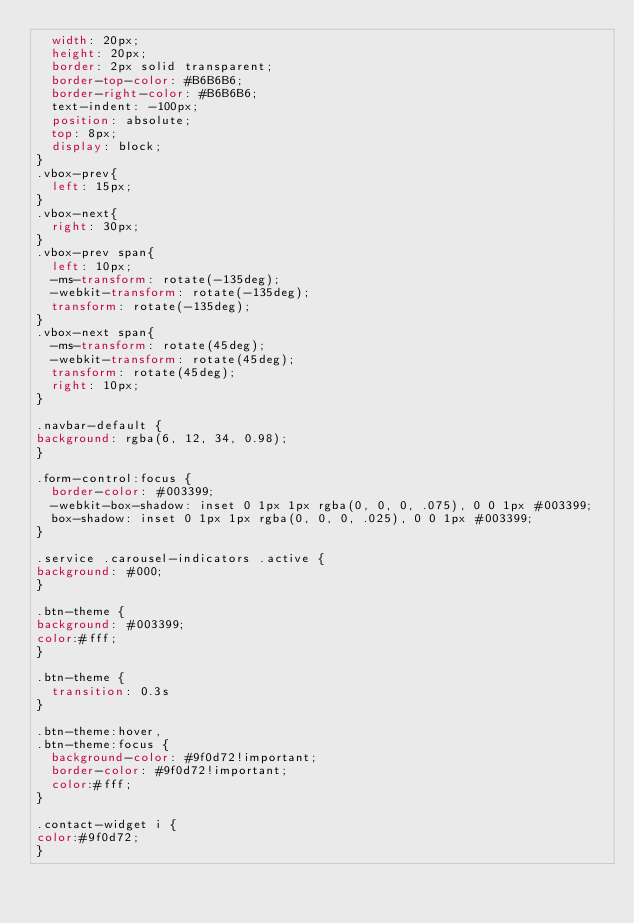Convert code to text. <code><loc_0><loc_0><loc_500><loc_500><_CSS_>  width: 20px;
  height: 20px;
  border: 2px solid transparent;
  border-top-color: #B6B6B6;
  border-right-color: #B6B6B6;
  text-indent: -100px;
  position: absolute;
  top: 8px;
  display: block;
}
.vbox-prev{
  left: 15px;
}
.vbox-next{
  right: 30px;
}
.vbox-prev span{
  left: 10px;
  -ms-transform: rotate(-135deg);
  -webkit-transform: rotate(-135deg);
  transform: rotate(-135deg);
}
.vbox-next span{
  -ms-transform: rotate(45deg);
  -webkit-transform: rotate(45deg);
  transform: rotate(45deg);
  right: 10px;
}

.navbar-default {
background: rgba(6, 12, 34, 0.98);
}

.form-control:focus {
  border-color: #003399;
  -webkit-box-shadow: inset 0 1px 1px rgba(0, 0, 0, .075), 0 0 1px #003399;
  box-shadow: inset 0 1px 1px rgba(0, 0, 0, .025), 0 0 1px #003399;
}

.service .carousel-indicators .active {
background: #000;
}

.btn-theme {
background: #003399;
color:#fff;
}

.btn-theme {
  transition: 0.3s
}

.btn-theme:hover,
.btn-theme:focus {
  background-color: #9f0d72!important;
  border-color: #9f0d72!important;
  color:#fff;
}

.contact-widget i {
color:#9f0d72;    
}
</code> 